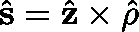<formula> <loc_0><loc_0><loc_500><loc_500>\hat { s } = \hat { z } \times \hat { \rho }</formula> 